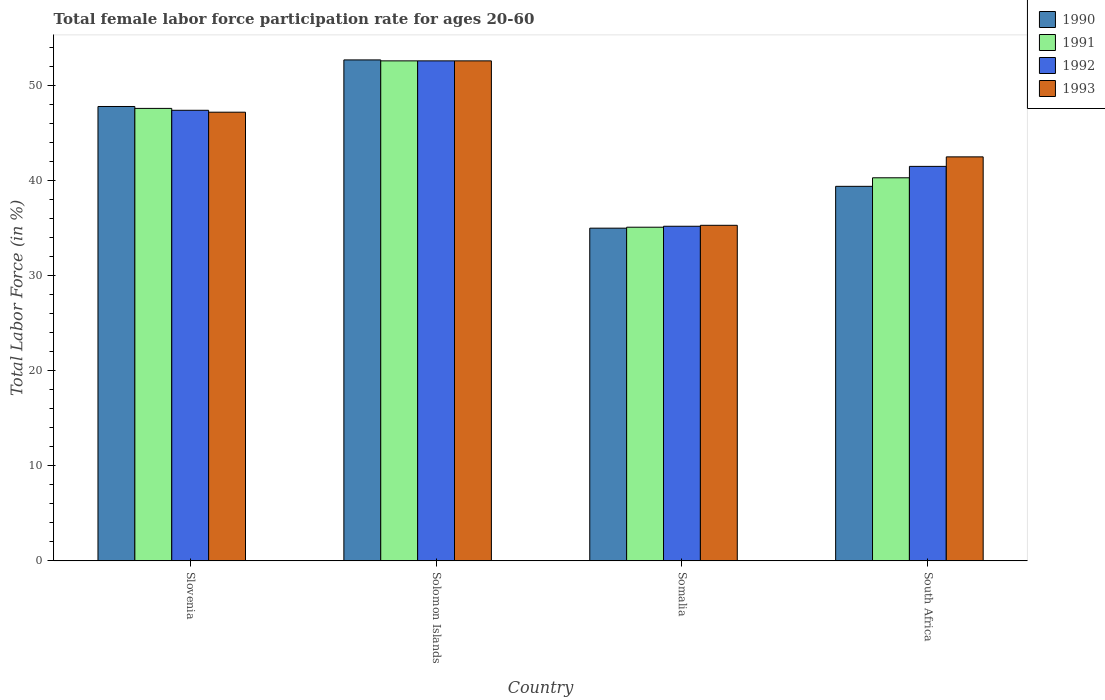How many different coloured bars are there?
Provide a short and direct response. 4. How many groups of bars are there?
Offer a terse response. 4. Are the number of bars per tick equal to the number of legend labels?
Provide a succinct answer. Yes. What is the label of the 3rd group of bars from the left?
Your response must be concise. Somalia. What is the female labor force participation rate in 1990 in Solomon Islands?
Offer a very short reply. 52.7. Across all countries, what is the maximum female labor force participation rate in 1993?
Provide a short and direct response. 52.6. Across all countries, what is the minimum female labor force participation rate in 1992?
Give a very brief answer. 35.2. In which country was the female labor force participation rate in 1993 maximum?
Offer a very short reply. Solomon Islands. In which country was the female labor force participation rate in 1993 minimum?
Offer a very short reply. Somalia. What is the total female labor force participation rate in 1992 in the graph?
Provide a succinct answer. 176.7. What is the difference between the female labor force participation rate in 1990 in Solomon Islands and that in Somalia?
Keep it short and to the point. 17.7. What is the difference between the female labor force participation rate in 1993 in Somalia and the female labor force participation rate in 1990 in South Africa?
Provide a succinct answer. -4.1. What is the average female labor force participation rate in 1991 per country?
Your answer should be compact. 43.9. What is the difference between the female labor force participation rate of/in 1992 and female labor force participation rate of/in 1990 in Somalia?
Your response must be concise. 0.2. What is the ratio of the female labor force participation rate in 1993 in Solomon Islands to that in South Africa?
Make the answer very short. 1.24. Is the female labor force participation rate in 1992 in Solomon Islands less than that in Somalia?
Your answer should be very brief. No. Is the difference between the female labor force participation rate in 1992 in Solomon Islands and Somalia greater than the difference between the female labor force participation rate in 1990 in Solomon Islands and Somalia?
Give a very brief answer. No. What is the difference between the highest and the second highest female labor force participation rate in 1990?
Ensure brevity in your answer.  13.3. What is the difference between the highest and the lowest female labor force participation rate in 1990?
Your response must be concise. 17.7. In how many countries, is the female labor force participation rate in 1990 greater than the average female labor force participation rate in 1990 taken over all countries?
Make the answer very short. 2. What does the 3rd bar from the left in Slovenia represents?
Your answer should be compact. 1992. What does the 3rd bar from the right in Somalia represents?
Provide a succinct answer. 1991. Is it the case that in every country, the sum of the female labor force participation rate in 1990 and female labor force participation rate in 1991 is greater than the female labor force participation rate in 1992?
Offer a very short reply. Yes. Are all the bars in the graph horizontal?
Provide a succinct answer. No. What is the difference between two consecutive major ticks on the Y-axis?
Offer a terse response. 10. Does the graph contain any zero values?
Ensure brevity in your answer.  No. Where does the legend appear in the graph?
Your answer should be compact. Top right. How many legend labels are there?
Provide a short and direct response. 4. How are the legend labels stacked?
Make the answer very short. Vertical. What is the title of the graph?
Your response must be concise. Total female labor force participation rate for ages 20-60. What is the label or title of the X-axis?
Your answer should be very brief. Country. What is the label or title of the Y-axis?
Provide a short and direct response. Total Labor Force (in %). What is the Total Labor Force (in %) in 1990 in Slovenia?
Your answer should be compact. 47.8. What is the Total Labor Force (in %) of 1991 in Slovenia?
Your answer should be very brief. 47.6. What is the Total Labor Force (in %) in 1992 in Slovenia?
Give a very brief answer. 47.4. What is the Total Labor Force (in %) in 1993 in Slovenia?
Your response must be concise. 47.2. What is the Total Labor Force (in %) in 1990 in Solomon Islands?
Make the answer very short. 52.7. What is the Total Labor Force (in %) in 1991 in Solomon Islands?
Ensure brevity in your answer.  52.6. What is the Total Labor Force (in %) of 1992 in Solomon Islands?
Keep it short and to the point. 52.6. What is the Total Labor Force (in %) of 1993 in Solomon Islands?
Your answer should be compact. 52.6. What is the Total Labor Force (in %) in 1990 in Somalia?
Your answer should be very brief. 35. What is the Total Labor Force (in %) in 1991 in Somalia?
Your response must be concise. 35.1. What is the Total Labor Force (in %) in 1992 in Somalia?
Make the answer very short. 35.2. What is the Total Labor Force (in %) of 1993 in Somalia?
Offer a very short reply. 35.3. What is the Total Labor Force (in %) of 1990 in South Africa?
Your answer should be compact. 39.4. What is the Total Labor Force (in %) of 1991 in South Africa?
Ensure brevity in your answer.  40.3. What is the Total Labor Force (in %) in 1992 in South Africa?
Provide a short and direct response. 41.5. What is the Total Labor Force (in %) of 1993 in South Africa?
Provide a succinct answer. 42.5. Across all countries, what is the maximum Total Labor Force (in %) of 1990?
Make the answer very short. 52.7. Across all countries, what is the maximum Total Labor Force (in %) in 1991?
Your answer should be compact. 52.6. Across all countries, what is the maximum Total Labor Force (in %) of 1992?
Keep it short and to the point. 52.6. Across all countries, what is the maximum Total Labor Force (in %) of 1993?
Your response must be concise. 52.6. Across all countries, what is the minimum Total Labor Force (in %) of 1991?
Your answer should be compact. 35.1. Across all countries, what is the minimum Total Labor Force (in %) in 1992?
Give a very brief answer. 35.2. Across all countries, what is the minimum Total Labor Force (in %) in 1993?
Keep it short and to the point. 35.3. What is the total Total Labor Force (in %) of 1990 in the graph?
Your answer should be compact. 174.9. What is the total Total Labor Force (in %) of 1991 in the graph?
Your answer should be very brief. 175.6. What is the total Total Labor Force (in %) in 1992 in the graph?
Offer a very short reply. 176.7. What is the total Total Labor Force (in %) of 1993 in the graph?
Provide a succinct answer. 177.6. What is the difference between the Total Labor Force (in %) in 1990 in Slovenia and that in Solomon Islands?
Keep it short and to the point. -4.9. What is the difference between the Total Labor Force (in %) of 1992 in Slovenia and that in Solomon Islands?
Provide a succinct answer. -5.2. What is the difference between the Total Labor Force (in %) of 1993 in Slovenia and that in Solomon Islands?
Keep it short and to the point. -5.4. What is the difference between the Total Labor Force (in %) of 1990 in Slovenia and that in Somalia?
Make the answer very short. 12.8. What is the difference between the Total Labor Force (in %) in 1990 in Slovenia and that in South Africa?
Provide a short and direct response. 8.4. What is the difference between the Total Labor Force (in %) of 1993 in Slovenia and that in South Africa?
Provide a succinct answer. 4.7. What is the difference between the Total Labor Force (in %) of 1990 in Solomon Islands and that in Somalia?
Make the answer very short. 17.7. What is the difference between the Total Labor Force (in %) in 1991 in Solomon Islands and that in Somalia?
Offer a very short reply. 17.5. What is the difference between the Total Labor Force (in %) in 1993 in Solomon Islands and that in Somalia?
Offer a very short reply. 17.3. What is the difference between the Total Labor Force (in %) in 1991 in Solomon Islands and that in South Africa?
Your answer should be compact. 12.3. What is the difference between the Total Labor Force (in %) of 1993 in Solomon Islands and that in South Africa?
Your answer should be very brief. 10.1. What is the difference between the Total Labor Force (in %) in 1990 in Somalia and that in South Africa?
Provide a succinct answer. -4.4. What is the difference between the Total Labor Force (in %) in 1991 in Somalia and that in South Africa?
Keep it short and to the point. -5.2. What is the difference between the Total Labor Force (in %) of 1990 in Slovenia and the Total Labor Force (in %) of 1992 in Solomon Islands?
Provide a short and direct response. -4.8. What is the difference between the Total Labor Force (in %) in 1991 in Slovenia and the Total Labor Force (in %) in 1993 in Solomon Islands?
Your response must be concise. -5. What is the difference between the Total Labor Force (in %) in 1990 in Slovenia and the Total Labor Force (in %) in 1992 in Somalia?
Offer a terse response. 12.6. What is the difference between the Total Labor Force (in %) of 1990 in Slovenia and the Total Labor Force (in %) of 1993 in Somalia?
Your answer should be very brief. 12.5. What is the difference between the Total Labor Force (in %) in 1991 in Slovenia and the Total Labor Force (in %) in 1993 in Somalia?
Offer a terse response. 12.3. What is the difference between the Total Labor Force (in %) in 1992 in Slovenia and the Total Labor Force (in %) in 1993 in Somalia?
Make the answer very short. 12.1. What is the difference between the Total Labor Force (in %) of 1990 in Slovenia and the Total Labor Force (in %) of 1991 in South Africa?
Your answer should be very brief. 7.5. What is the difference between the Total Labor Force (in %) in 1990 in Slovenia and the Total Labor Force (in %) in 1992 in South Africa?
Provide a succinct answer. 6.3. What is the difference between the Total Labor Force (in %) of 1990 in Slovenia and the Total Labor Force (in %) of 1993 in South Africa?
Make the answer very short. 5.3. What is the difference between the Total Labor Force (in %) in 1992 in Slovenia and the Total Labor Force (in %) in 1993 in South Africa?
Provide a short and direct response. 4.9. What is the difference between the Total Labor Force (in %) of 1990 in Solomon Islands and the Total Labor Force (in %) of 1991 in Somalia?
Keep it short and to the point. 17.6. What is the difference between the Total Labor Force (in %) in 1990 in Solomon Islands and the Total Labor Force (in %) in 1993 in Somalia?
Your answer should be very brief. 17.4. What is the difference between the Total Labor Force (in %) of 1991 in Solomon Islands and the Total Labor Force (in %) of 1992 in Somalia?
Offer a very short reply. 17.4. What is the difference between the Total Labor Force (in %) in 1991 in Solomon Islands and the Total Labor Force (in %) in 1993 in Somalia?
Offer a very short reply. 17.3. What is the difference between the Total Labor Force (in %) of 1990 in Solomon Islands and the Total Labor Force (in %) of 1992 in South Africa?
Keep it short and to the point. 11.2. What is the difference between the Total Labor Force (in %) in 1991 in Solomon Islands and the Total Labor Force (in %) in 1992 in South Africa?
Your response must be concise. 11.1. What is the difference between the Total Labor Force (in %) in 1991 in Solomon Islands and the Total Labor Force (in %) in 1993 in South Africa?
Your response must be concise. 10.1. What is the difference between the Total Labor Force (in %) of 1992 in Solomon Islands and the Total Labor Force (in %) of 1993 in South Africa?
Offer a very short reply. 10.1. What is the difference between the Total Labor Force (in %) of 1990 in Somalia and the Total Labor Force (in %) of 1993 in South Africa?
Offer a very short reply. -7.5. What is the difference between the Total Labor Force (in %) of 1991 in Somalia and the Total Labor Force (in %) of 1993 in South Africa?
Offer a terse response. -7.4. What is the difference between the Total Labor Force (in %) of 1992 in Somalia and the Total Labor Force (in %) of 1993 in South Africa?
Provide a succinct answer. -7.3. What is the average Total Labor Force (in %) in 1990 per country?
Keep it short and to the point. 43.73. What is the average Total Labor Force (in %) in 1991 per country?
Your answer should be compact. 43.9. What is the average Total Labor Force (in %) of 1992 per country?
Ensure brevity in your answer.  44.17. What is the average Total Labor Force (in %) of 1993 per country?
Your response must be concise. 44.4. What is the difference between the Total Labor Force (in %) of 1990 and Total Labor Force (in %) of 1992 in Slovenia?
Give a very brief answer. 0.4. What is the difference between the Total Labor Force (in %) in 1990 and Total Labor Force (in %) in 1993 in Slovenia?
Your answer should be very brief. 0.6. What is the difference between the Total Labor Force (in %) in 1991 and Total Labor Force (in %) in 1992 in Slovenia?
Provide a short and direct response. 0.2. What is the difference between the Total Labor Force (in %) in 1992 and Total Labor Force (in %) in 1993 in Slovenia?
Ensure brevity in your answer.  0.2. What is the difference between the Total Labor Force (in %) in 1991 and Total Labor Force (in %) in 1993 in Solomon Islands?
Keep it short and to the point. 0. What is the difference between the Total Labor Force (in %) in 1991 and Total Labor Force (in %) in 1993 in Somalia?
Offer a terse response. -0.2. What is the difference between the Total Labor Force (in %) of 1992 and Total Labor Force (in %) of 1993 in Somalia?
Ensure brevity in your answer.  -0.1. What is the difference between the Total Labor Force (in %) in 1990 and Total Labor Force (in %) in 1991 in South Africa?
Make the answer very short. -0.9. What is the difference between the Total Labor Force (in %) of 1990 and Total Labor Force (in %) of 1993 in South Africa?
Offer a terse response. -3.1. What is the difference between the Total Labor Force (in %) of 1991 and Total Labor Force (in %) of 1992 in South Africa?
Keep it short and to the point. -1.2. What is the difference between the Total Labor Force (in %) in 1991 and Total Labor Force (in %) in 1993 in South Africa?
Provide a short and direct response. -2.2. What is the difference between the Total Labor Force (in %) of 1992 and Total Labor Force (in %) of 1993 in South Africa?
Make the answer very short. -1. What is the ratio of the Total Labor Force (in %) in 1990 in Slovenia to that in Solomon Islands?
Your answer should be compact. 0.91. What is the ratio of the Total Labor Force (in %) of 1991 in Slovenia to that in Solomon Islands?
Provide a succinct answer. 0.9. What is the ratio of the Total Labor Force (in %) of 1992 in Slovenia to that in Solomon Islands?
Provide a short and direct response. 0.9. What is the ratio of the Total Labor Force (in %) of 1993 in Slovenia to that in Solomon Islands?
Provide a short and direct response. 0.9. What is the ratio of the Total Labor Force (in %) of 1990 in Slovenia to that in Somalia?
Your answer should be very brief. 1.37. What is the ratio of the Total Labor Force (in %) of 1991 in Slovenia to that in Somalia?
Ensure brevity in your answer.  1.36. What is the ratio of the Total Labor Force (in %) of 1992 in Slovenia to that in Somalia?
Offer a terse response. 1.35. What is the ratio of the Total Labor Force (in %) of 1993 in Slovenia to that in Somalia?
Offer a terse response. 1.34. What is the ratio of the Total Labor Force (in %) of 1990 in Slovenia to that in South Africa?
Your response must be concise. 1.21. What is the ratio of the Total Labor Force (in %) in 1991 in Slovenia to that in South Africa?
Keep it short and to the point. 1.18. What is the ratio of the Total Labor Force (in %) of 1992 in Slovenia to that in South Africa?
Offer a very short reply. 1.14. What is the ratio of the Total Labor Force (in %) in 1993 in Slovenia to that in South Africa?
Make the answer very short. 1.11. What is the ratio of the Total Labor Force (in %) in 1990 in Solomon Islands to that in Somalia?
Your answer should be very brief. 1.51. What is the ratio of the Total Labor Force (in %) of 1991 in Solomon Islands to that in Somalia?
Your response must be concise. 1.5. What is the ratio of the Total Labor Force (in %) in 1992 in Solomon Islands to that in Somalia?
Your answer should be compact. 1.49. What is the ratio of the Total Labor Force (in %) of 1993 in Solomon Islands to that in Somalia?
Provide a succinct answer. 1.49. What is the ratio of the Total Labor Force (in %) of 1990 in Solomon Islands to that in South Africa?
Provide a short and direct response. 1.34. What is the ratio of the Total Labor Force (in %) of 1991 in Solomon Islands to that in South Africa?
Keep it short and to the point. 1.31. What is the ratio of the Total Labor Force (in %) of 1992 in Solomon Islands to that in South Africa?
Your answer should be compact. 1.27. What is the ratio of the Total Labor Force (in %) in 1993 in Solomon Islands to that in South Africa?
Your answer should be very brief. 1.24. What is the ratio of the Total Labor Force (in %) in 1990 in Somalia to that in South Africa?
Your answer should be compact. 0.89. What is the ratio of the Total Labor Force (in %) of 1991 in Somalia to that in South Africa?
Give a very brief answer. 0.87. What is the ratio of the Total Labor Force (in %) in 1992 in Somalia to that in South Africa?
Offer a terse response. 0.85. What is the ratio of the Total Labor Force (in %) of 1993 in Somalia to that in South Africa?
Give a very brief answer. 0.83. What is the difference between the highest and the second highest Total Labor Force (in %) of 1990?
Offer a terse response. 4.9. What is the difference between the highest and the second highest Total Labor Force (in %) in 1991?
Offer a terse response. 5. What is the difference between the highest and the second highest Total Labor Force (in %) in 1993?
Your answer should be very brief. 5.4. What is the difference between the highest and the lowest Total Labor Force (in %) in 1990?
Keep it short and to the point. 17.7. What is the difference between the highest and the lowest Total Labor Force (in %) of 1991?
Give a very brief answer. 17.5. What is the difference between the highest and the lowest Total Labor Force (in %) of 1992?
Your response must be concise. 17.4. 